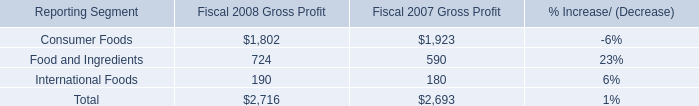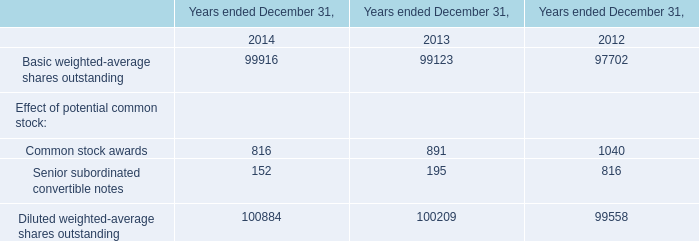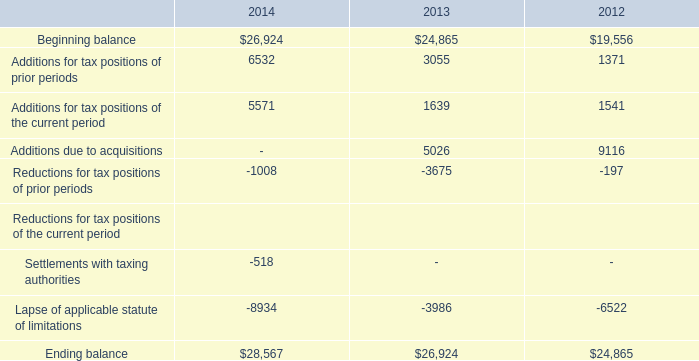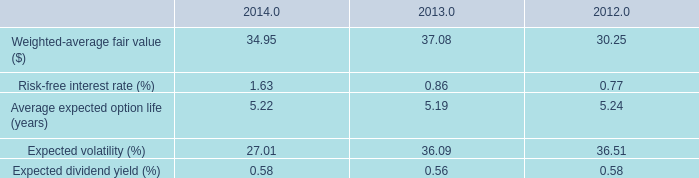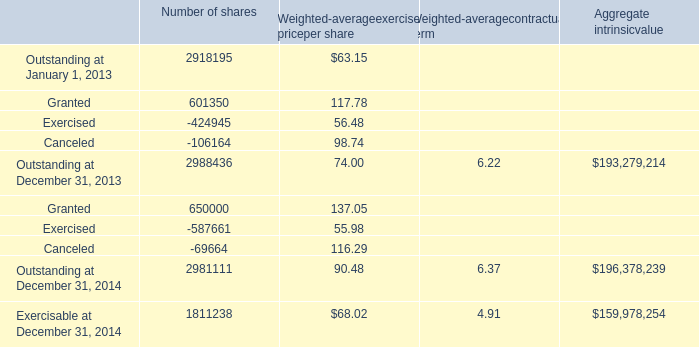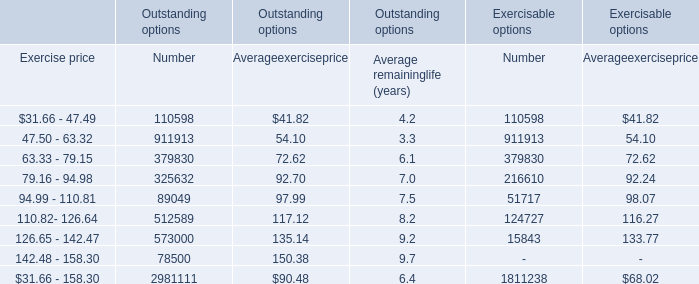What's the growth rate of Granted for number of shares in 2014? 
Computations: ((650000 - 601350) / 601350)
Answer: 0.0809. 